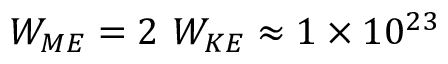<formula> <loc_0><loc_0><loc_500><loc_500>W _ { M E } = 2 \ W _ { K E } \approx 1 \times 1 0 ^ { 2 3 }</formula> 